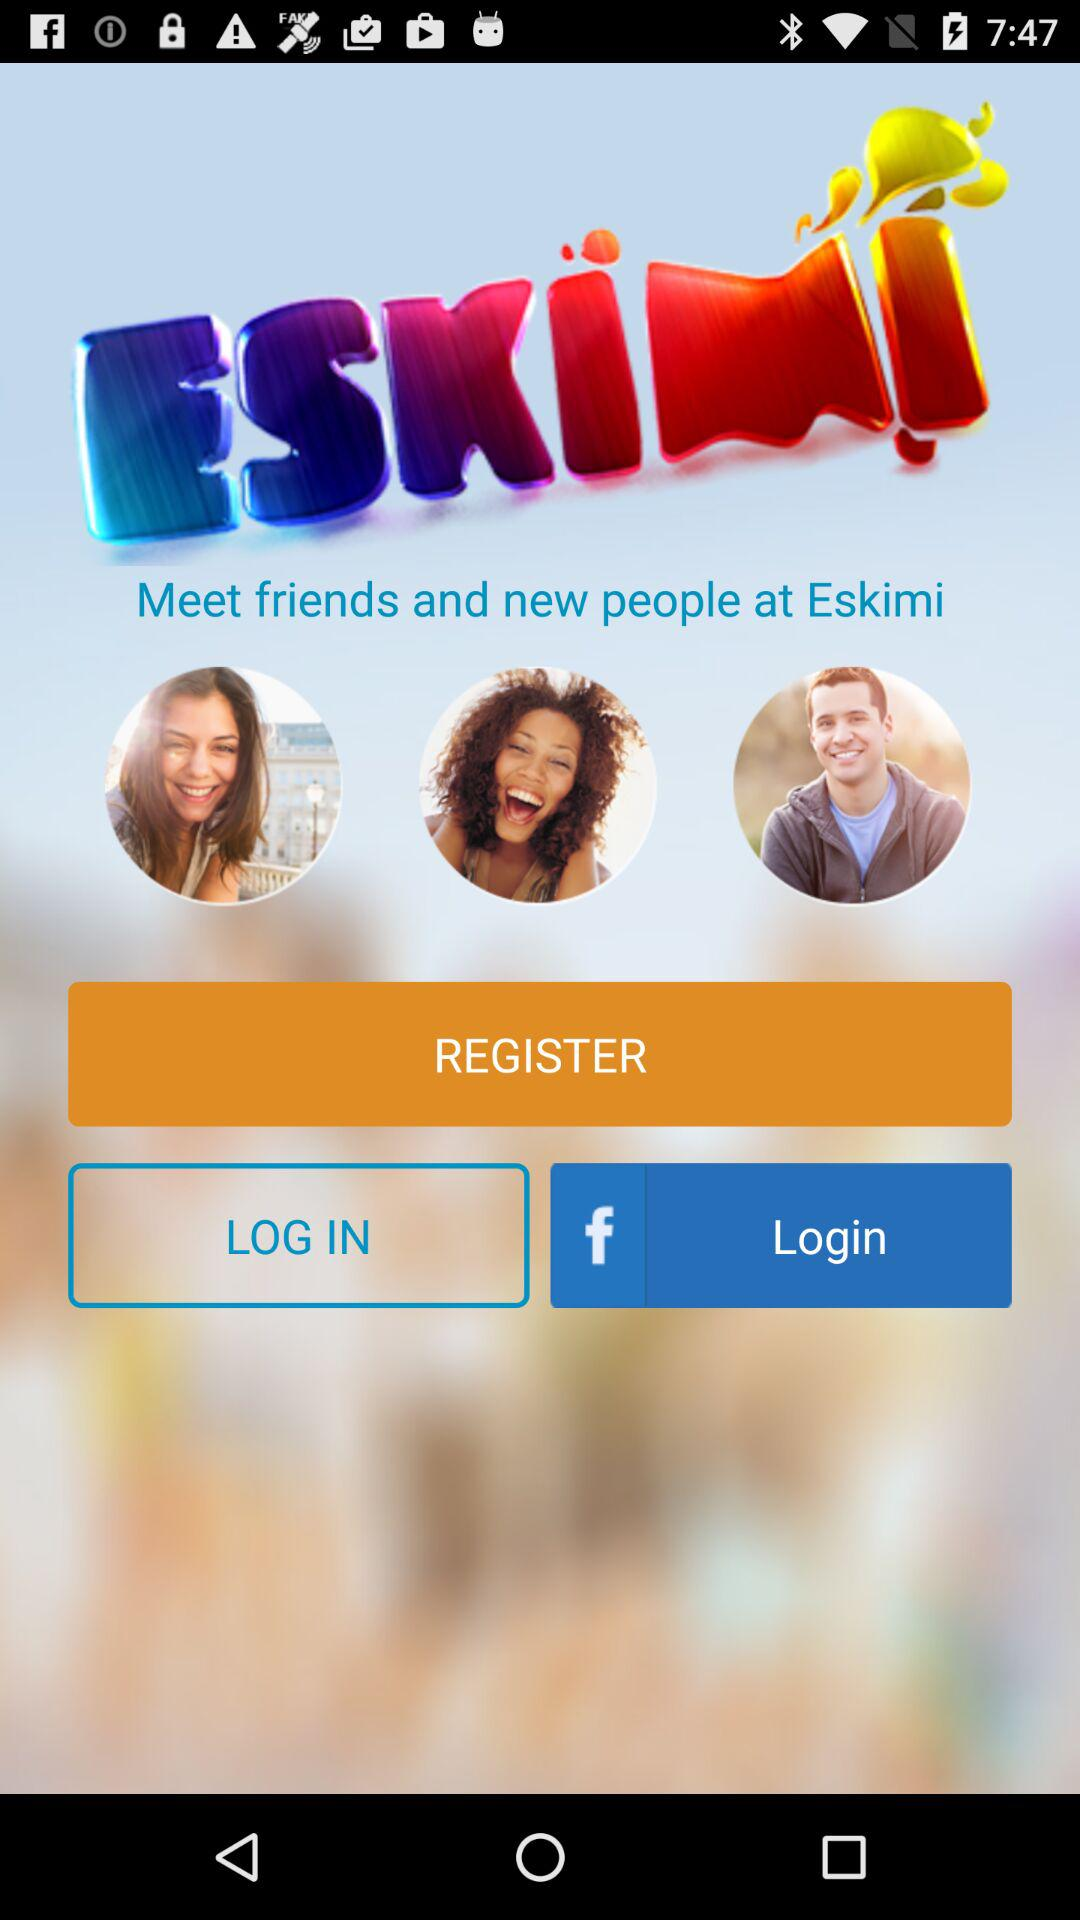How many people have joined "Eskimi"?
When the provided information is insufficient, respond with <no answer>. <no answer> 